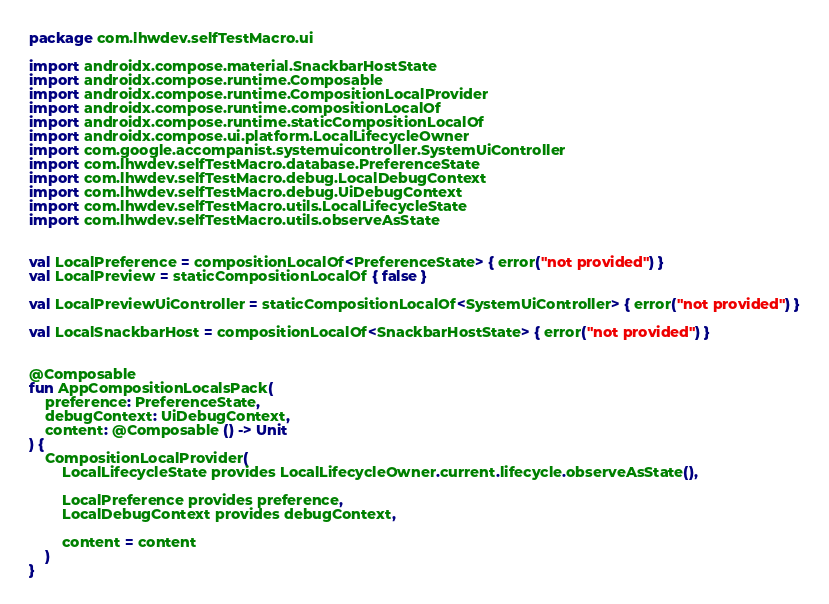<code> <loc_0><loc_0><loc_500><loc_500><_Kotlin_>package com.lhwdev.selfTestMacro.ui

import androidx.compose.material.SnackbarHostState
import androidx.compose.runtime.Composable
import androidx.compose.runtime.CompositionLocalProvider
import androidx.compose.runtime.compositionLocalOf
import androidx.compose.runtime.staticCompositionLocalOf
import androidx.compose.ui.platform.LocalLifecycleOwner
import com.google.accompanist.systemuicontroller.SystemUiController
import com.lhwdev.selfTestMacro.database.PreferenceState
import com.lhwdev.selfTestMacro.debug.LocalDebugContext
import com.lhwdev.selfTestMacro.debug.UiDebugContext
import com.lhwdev.selfTestMacro.utils.LocalLifecycleState
import com.lhwdev.selfTestMacro.utils.observeAsState


val LocalPreference = compositionLocalOf<PreferenceState> { error("not provided") }
val LocalPreview = staticCompositionLocalOf { false }

val LocalPreviewUiController = staticCompositionLocalOf<SystemUiController> { error("not provided") }

val LocalSnackbarHost = compositionLocalOf<SnackbarHostState> { error("not provided") }


@Composable
fun AppCompositionLocalsPack(
	preference: PreferenceState,
	debugContext: UiDebugContext,
	content: @Composable () -> Unit
) {
	CompositionLocalProvider(
		LocalLifecycleState provides LocalLifecycleOwner.current.lifecycle.observeAsState(),
		
		LocalPreference provides preference,
		LocalDebugContext provides debugContext,
		
		content = content
	)
}
</code> 